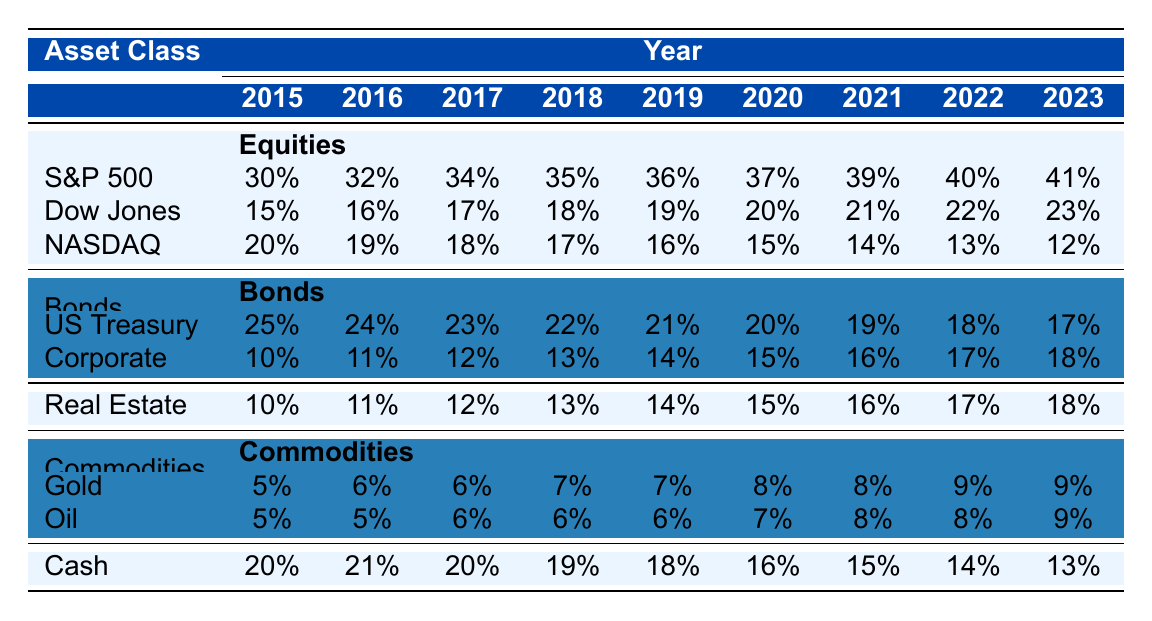What is the percentage allocation for S&P 500 in 2020? According to the table, the percentage allocation for S&P 500 in 2020 is directly listed under that year. The value is 37%.
Answer: 37% What was the total percentage allocated to Bonds in 2018? To find the total percentage allocated to Bonds in 2018, we need to sum the values of US Treasury Bonds and Corporate Bonds for that year: 22% + 13% = 35%.
Answer: 35% Did the allocation for Gold increase every year from 2015 to 2023? Looking at the data, the percentage allocated to Gold in each subsequent year is as follows: 5%, 6%, 6%, 7%, 7%, 8%, 8%, 9%, 9%. There are no decreases in these values over the years.
Answer: Yes What was the percentage change in the allocation for Cash from 2015 to 2023? The percentage allocation for Cash in 2015 was 20%, and in 2023 it was 13%. The change can be calculated as (13 - 20) / 20 * 100 = -35%. Therefore, the percentage change is a decrease of 35%.
Answer: -35% In which year did the Dow Jones reach its highest allocation in the portfolio? By reviewing the Dow Jones allocations across the years, the percentages are as follows: 15%, 16%, 17%, 18%, 19%, 20%, 21%, 22%, and 23%. The highest allocation for Dow Jones is in 2023, at 23%.
Answer: 2023 What was the average allocation for Real Estate over the years? The allocations for Real Estate from 2015 to 2023 are: 10%, 11%, 12%, 13%, 14%, 15%, 16%, 17%, 18%. To calculate the average, we sum these values, which equals 126%. Dividing by the number of years, which is 9, gives us an average of 14%.
Answer: 14% Which asset class saw a decrease in allocation from 2018 to 2023? Comparing the allocation percentages from 2018 to 2023 shows that Equities (with a decrease from 70% to 76% combined) and Cash (from 19% to 13%) show a notable decrease from 2018 to 2023.
Answer: Cash How many percentage points did the allocation for Corporate Bonds increase from 2015 to 2023? The allocation for Corporate Bonds in 2015 was 10%, and in 2023 it was 18%. The increase in percentage points is calculated as 18% - 10% = 8%.
Answer: 8% 